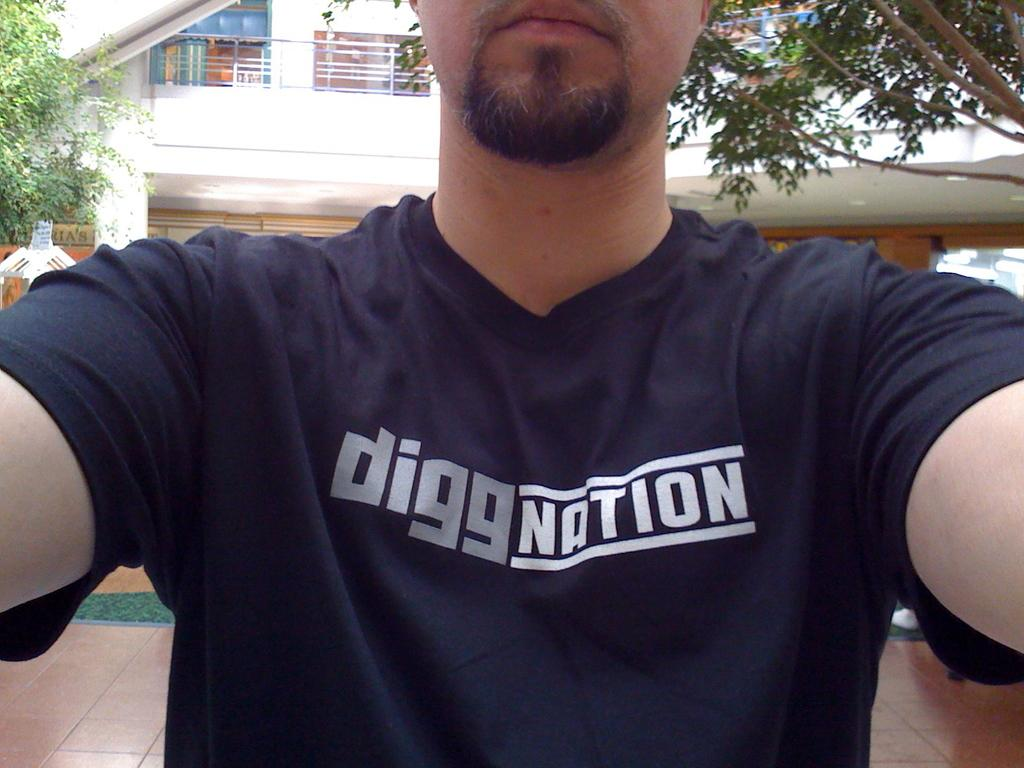<image>
Relay a brief, clear account of the picture shown. A man is wearing a blue t-shirt that says digg nation. 